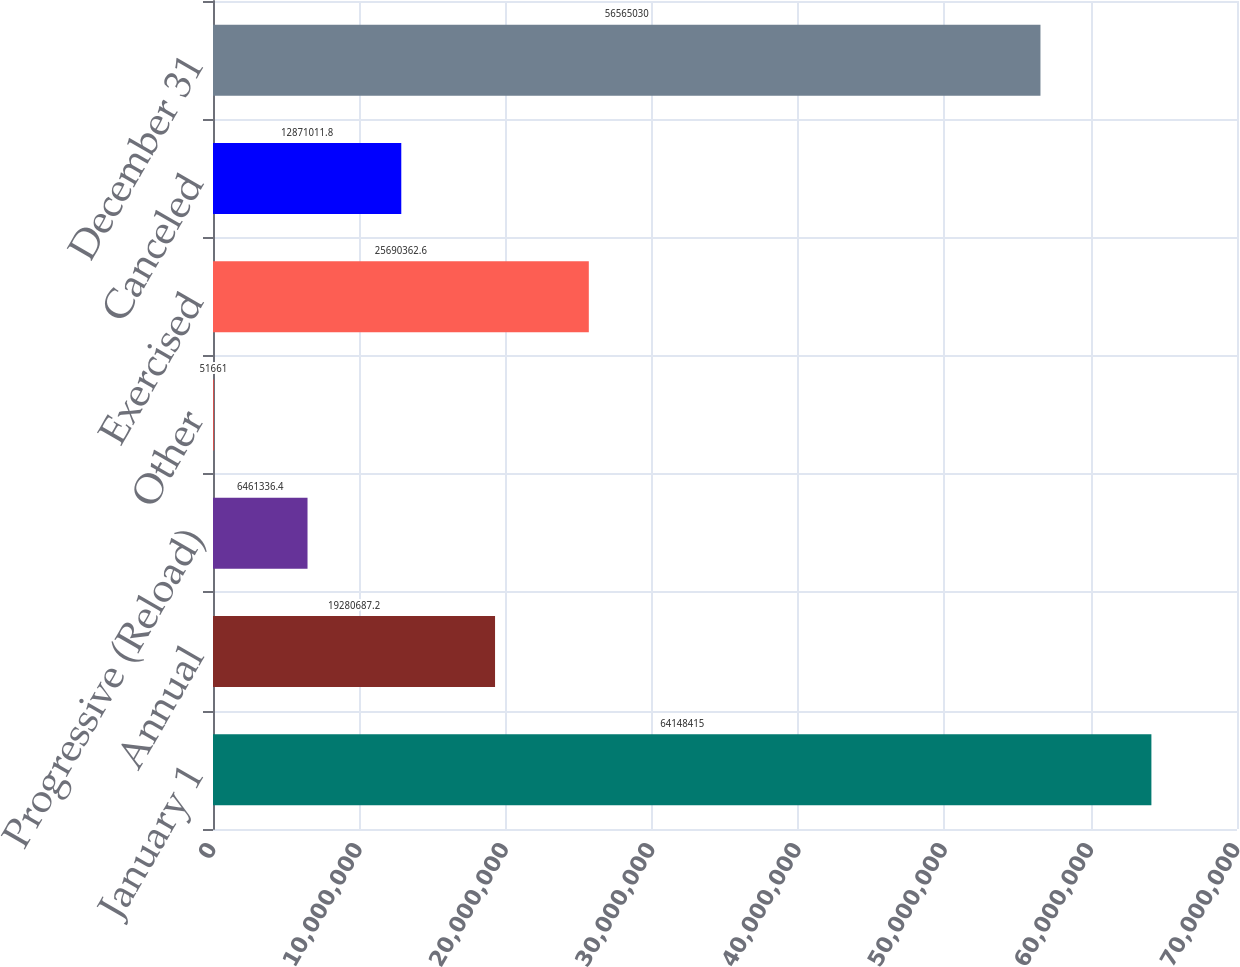Convert chart. <chart><loc_0><loc_0><loc_500><loc_500><bar_chart><fcel>January 1<fcel>Annual<fcel>Progressive (Reload)<fcel>Other<fcel>Exercised<fcel>Canceled<fcel>December 31<nl><fcel>6.41484e+07<fcel>1.92807e+07<fcel>6.46134e+06<fcel>51661<fcel>2.56904e+07<fcel>1.2871e+07<fcel>5.6565e+07<nl></chart> 